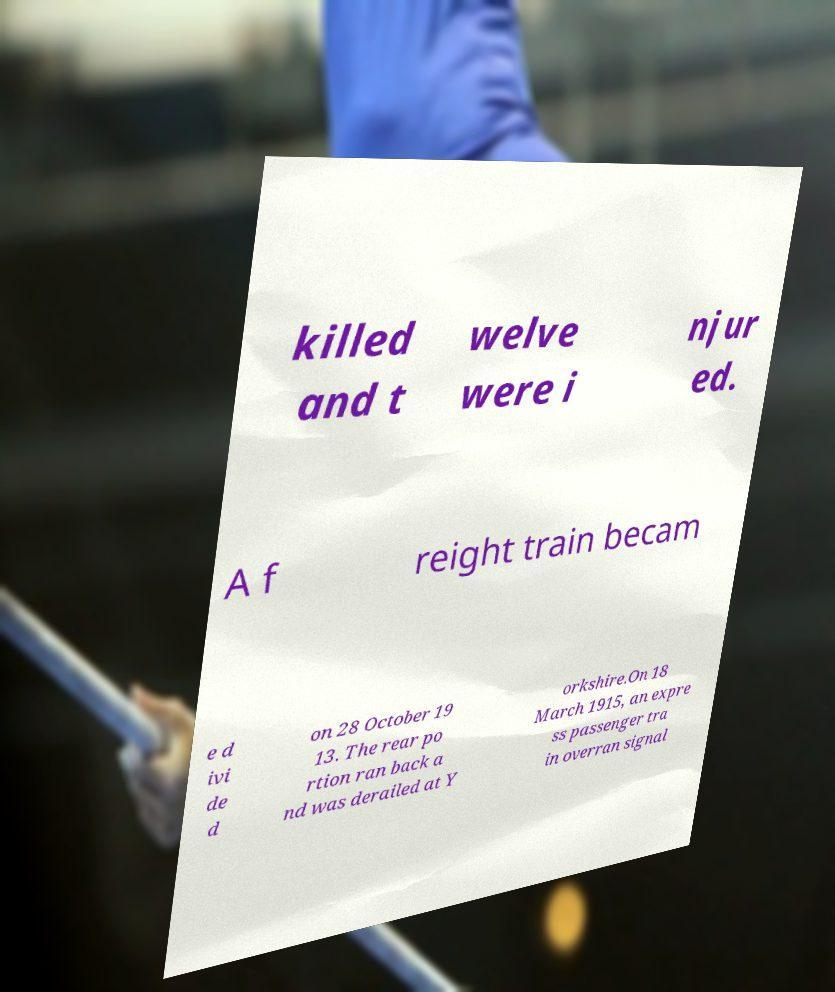Please read and relay the text visible in this image. What does it say? killed and t welve were i njur ed. A f reight train becam e d ivi de d on 28 October 19 13. The rear po rtion ran back a nd was derailed at Y orkshire.On 18 March 1915, an expre ss passenger tra in overran signal 